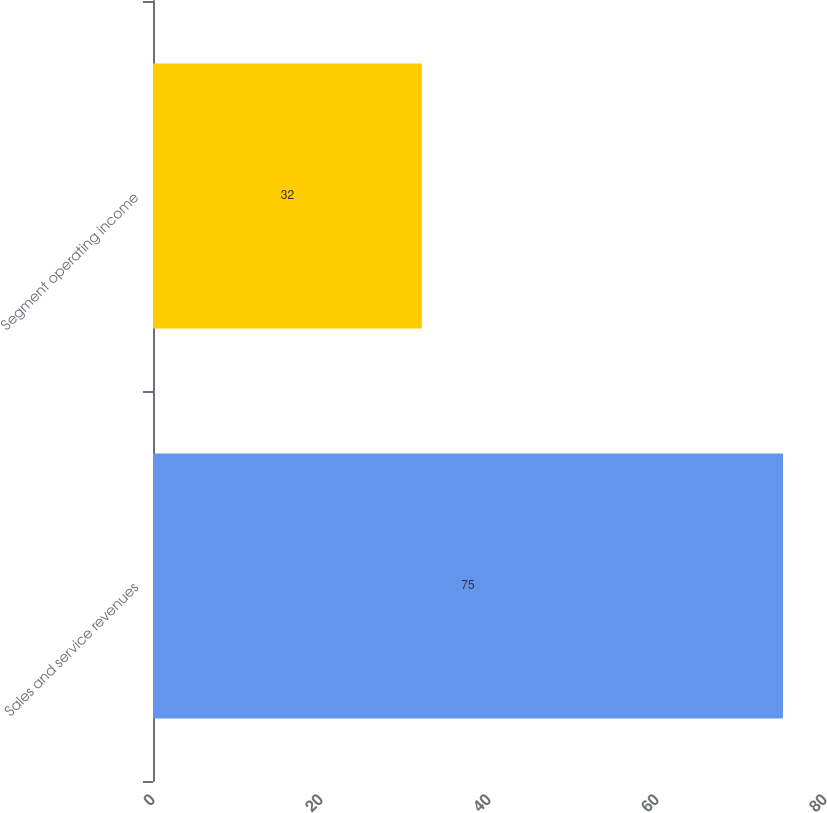Convert chart to OTSL. <chart><loc_0><loc_0><loc_500><loc_500><bar_chart><fcel>Sales and service revenues<fcel>Segment operating income<nl><fcel>75<fcel>32<nl></chart> 